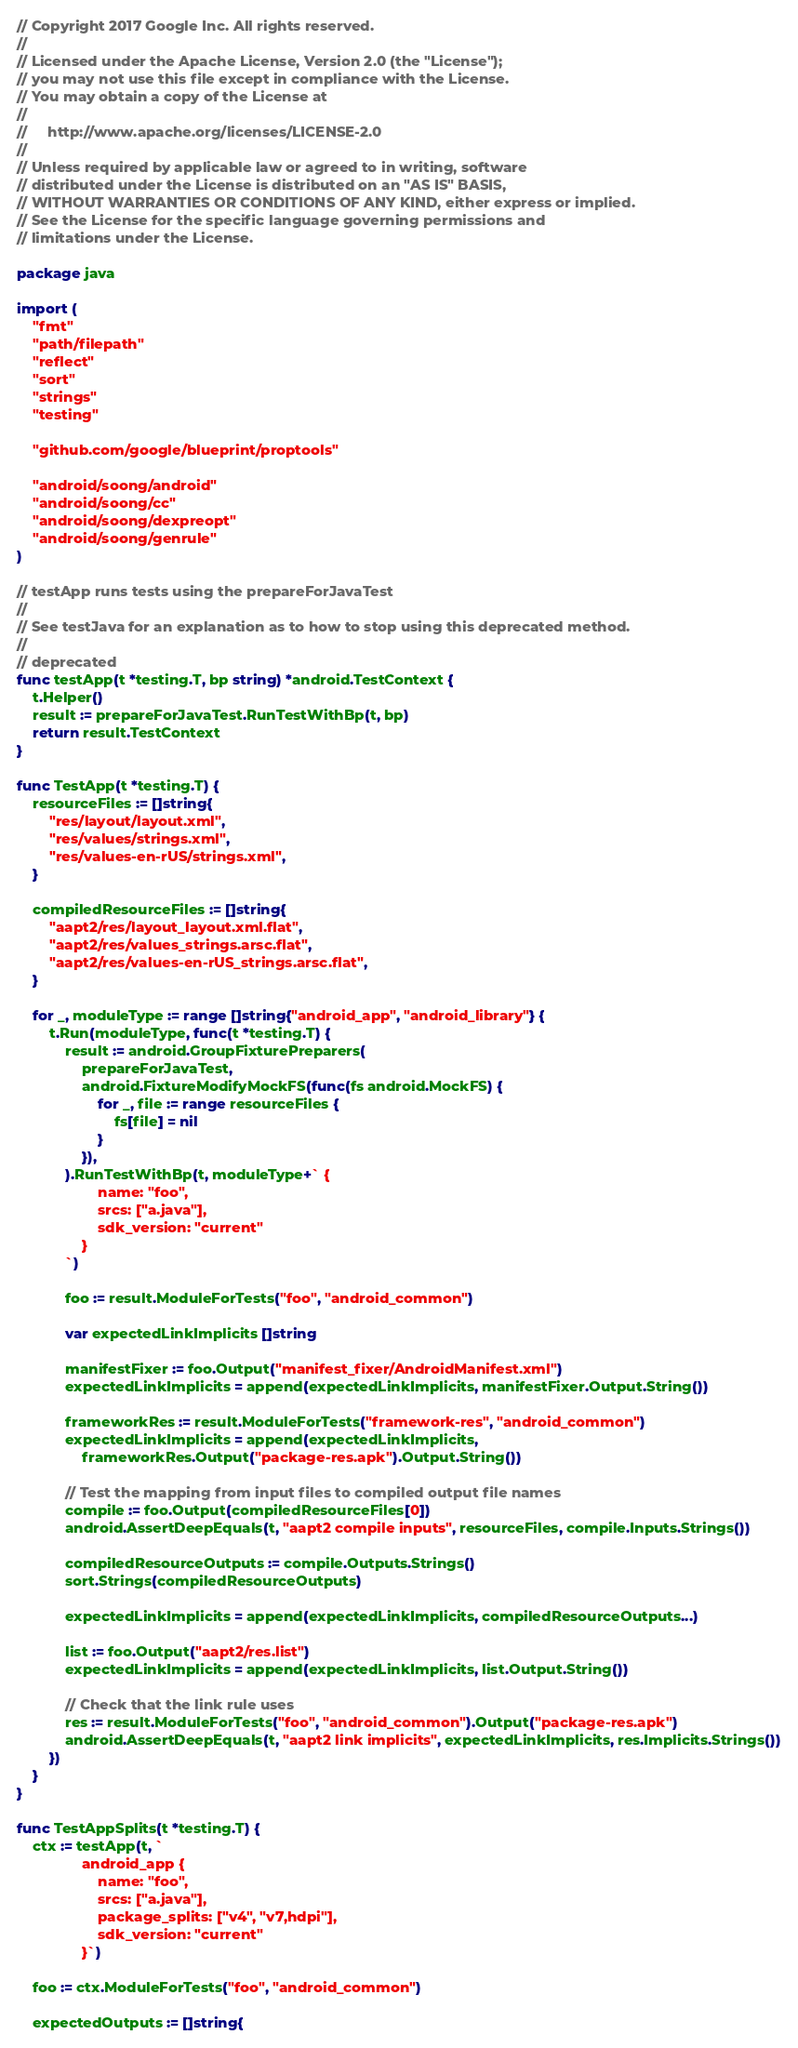Convert code to text. <code><loc_0><loc_0><loc_500><loc_500><_Go_>// Copyright 2017 Google Inc. All rights reserved.
//
// Licensed under the Apache License, Version 2.0 (the "License");
// you may not use this file except in compliance with the License.
// You may obtain a copy of the License at
//
//     http://www.apache.org/licenses/LICENSE-2.0
//
// Unless required by applicable law or agreed to in writing, software
// distributed under the License is distributed on an "AS IS" BASIS,
// WITHOUT WARRANTIES OR CONDITIONS OF ANY KIND, either express or implied.
// See the License for the specific language governing permissions and
// limitations under the License.

package java

import (
	"fmt"
	"path/filepath"
	"reflect"
	"sort"
	"strings"
	"testing"

	"github.com/google/blueprint/proptools"

	"android/soong/android"
	"android/soong/cc"
	"android/soong/dexpreopt"
	"android/soong/genrule"
)

// testApp runs tests using the prepareForJavaTest
//
// See testJava for an explanation as to how to stop using this deprecated method.
//
// deprecated
func testApp(t *testing.T, bp string) *android.TestContext {
	t.Helper()
	result := prepareForJavaTest.RunTestWithBp(t, bp)
	return result.TestContext
}

func TestApp(t *testing.T) {
	resourceFiles := []string{
		"res/layout/layout.xml",
		"res/values/strings.xml",
		"res/values-en-rUS/strings.xml",
	}

	compiledResourceFiles := []string{
		"aapt2/res/layout_layout.xml.flat",
		"aapt2/res/values_strings.arsc.flat",
		"aapt2/res/values-en-rUS_strings.arsc.flat",
	}

	for _, moduleType := range []string{"android_app", "android_library"} {
		t.Run(moduleType, func(t *testing.T) {
			result := android.GroupFixturePreparers(
				prepareForJavaTest,
				android.FixtureModifyMockFS(func(fs android.MockFS) {
					for _, file := range resourceFiles {
						fs[file] = nil
					}
				}),
			).RunTestWithBp(t, moduleType+` {
					name: "foo",
					srcs: ["a.java"],
					sdk_version: "current"
				}
			`)

			foo := result.ModuleForTests("foo", "android_common")

			var expectedLinkImplicits []string

			manifestFixer := foo.Output("manifest_fixer/AndroidManifest.xml")
			expectedLinkImplicits = append(expectedLinkImplicits, manifestFixer.Output.String())

			frameworkRes := result.ModuleForTests("framework-res", "android_common")
			expectedLinkImplicits = append(expectedLinkImplicits,
				frameworkRes.Output("package-res.apk").Output.String())

			// Test the mapping from input files to compiled output file names
			compile := foo.Output(compiledResourceFiles[0])
			android.AssertDeepEquals(t, "aapt2 compile inputs", resourceFiles, compile.Inputs.Strings())

			compiledResourceOutputs := compile.Outputs.Strings()
			sort.Strings(compiledResourceOutputs)

			expectedLinkImplicits = append(expectedLinkImplicits, compiledResourceOutputs...)

			list := foo.Output("aapt2/res.list")
			expectedLinkImplicits = append(expectedLinkImplicits, list.Output.String())

			// Check that the link rule uses
			res := result.ModuleForTests("foo", "android_common").Output("package-res.apk")
			android.AssertDeepEquals(t, "aapt2 link implicits", expectedLinkImplicits, res.Implicits.Strings())
		})
	}
}

func TestAppSplits(t *testing.T) {
	ctx := testApp(t, `
				android_app {
					name: "foo",
					srcs: ["a.java"],
					package_splits: ["v4", "v7,hdpi"],
					sdk_version: "current"
				}`)

	foo := ctx.ModuleForTests("foo", "android_common")

	expectedOutputs := []string{</code> 